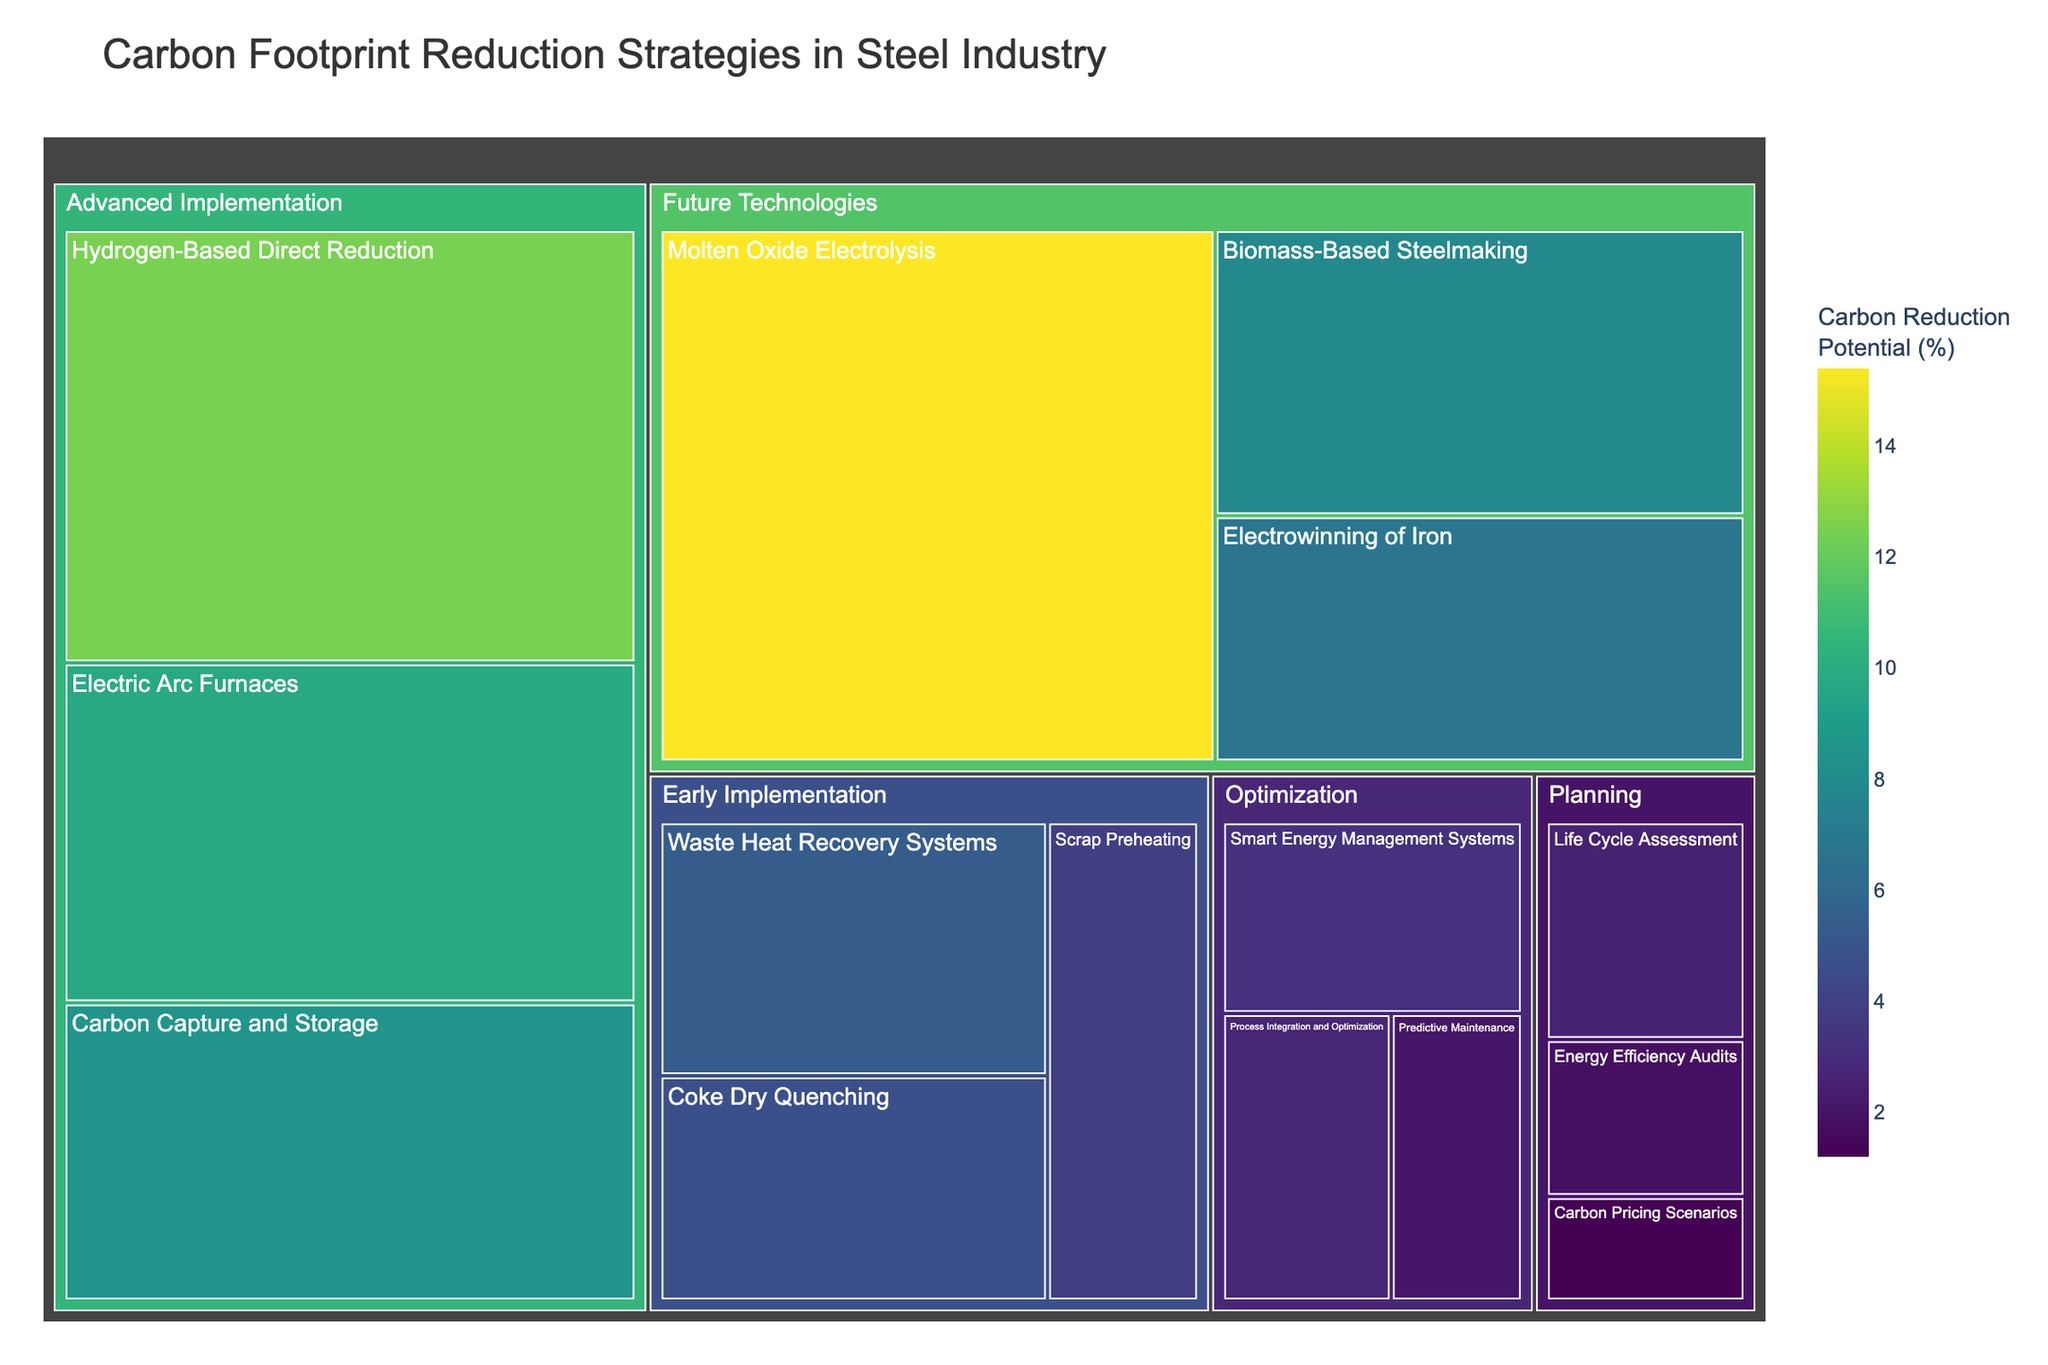What is the title of the treemap? The title is typically found prominently at the top of the figure and is intended to give a summary of what the figure is about. The title is "Carbon Footprint Reduction Strategies in Steel Industry."
Answer: Carbon Footprint Reduction Strategies in Steel Industry Which implementation stage has the highest carbon reduction potential? To find this, look for the stage with the largest sum of Carbon Reduction Potential values. The "Future Technologies" stage has the highest value, with individual contributions adding up to 30.1%.
Answer: Future Technologies Which strategy within the Advanced Implementation stage has the highest carbon reduction potential? Within the Advanced Implementation stage, compare the Carbon Reduction Potential values for all strategies. "Hydrogen-Based Direct Reduction" has the highest potential at 12.5%.
Answer: Hydrogen-Based Direct Reduction How does the carbon reduction potential of Smart Energy Management Systems compare to Predictive Maintenance? Find the values for Smart Energy Management Systems (3.2%) and Predictive Maintenance (2.1%) and compare them mathematically. 3.2 is greater than 2.1, thus Smart Energy Management Systems have a higher potential.
Answer: Smart Energy Management Systems > Predictive Maintenance What is the total carbon reduction potential for all strategies in the Planning stage? Add the values of all strategies in the Planning stage: 2.5% + 1.8% + 1.2% = 5.5%.
Answer: 5.5% Which strategy has the lowest carbon reduction potential? Scan through all strategies to find the one with the smallest value. "Carbon Pricing Scenarios" in the Planning stage has the lowest potential at 1.2%.
Answer: Carbon Pricing Scenarios What is the average carbon reduction potential of the strategies in the Optimization stage? Add all the potentials in the Optimization stage and divide by the number of strategies: (3.2% + 2.7% + 2.1%) / 3 = 8.0 / 3 = 2.67%.
Answer: 2.67% Is there a significant gap in carbon reduction potential between any two neighboring stages? Identify stages with close total potentials and compare them. Early Implementation has 13.9%, and Advanced Implementation has 30.9%, resulting in a gap of 17.0%, which is the largest gap between neighboring stages.
Answer: Early to Advanced Implementation What strategy in the Future Technologies stage has the second-highest carbon reduction potential? In the Future Technologies stage, compare values to find the second-highest. "Biomass-Based Steelmaking" has the second-highest potential, behind "Molten Oxide Electrolysis."
Answer: Biomass-Based Steelmaking 